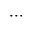Convert formula to latex. <formula><loc_0><loc_0><loc_500><loc_500>\cdots</formula> 